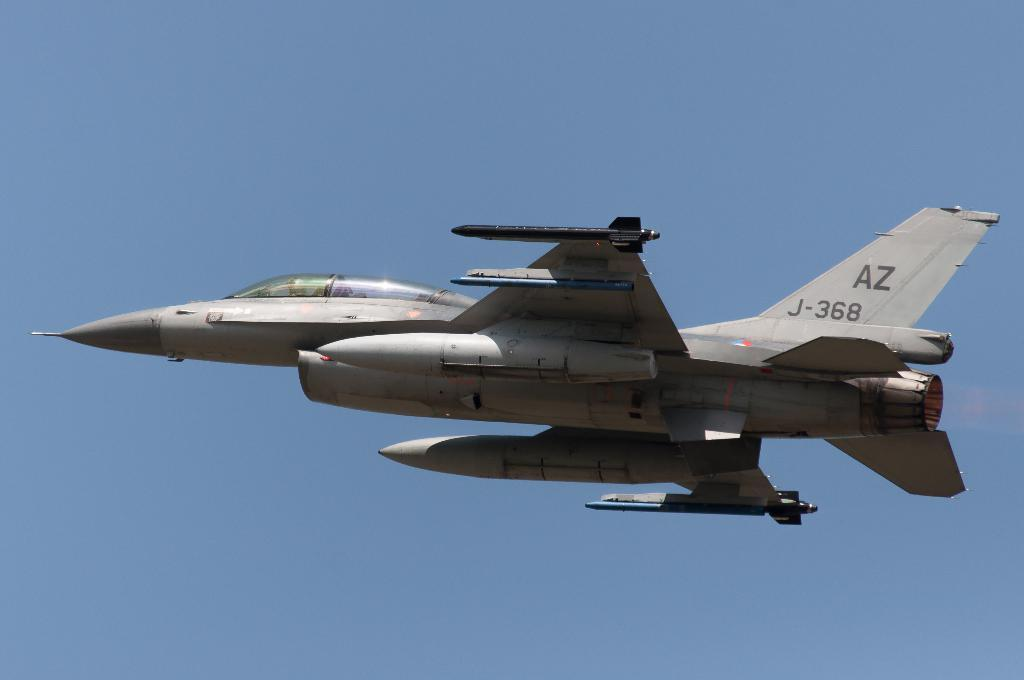What is the main subject of the image? The main subject of the image is an aircraft. What is the aircraft doing in the image? The aircraft is flying in the sky. Can you describe the person inside the aircraft? There is a person sitting in the aircraft. How would you describe the weather based on the image? The sky in the background is clear. Where is the edge of the aircraft located in the image? The concept of an "edge" of the aircraft is not applicable in this context, as the image does not show the aircraft from a perspective where edges would be visible. 